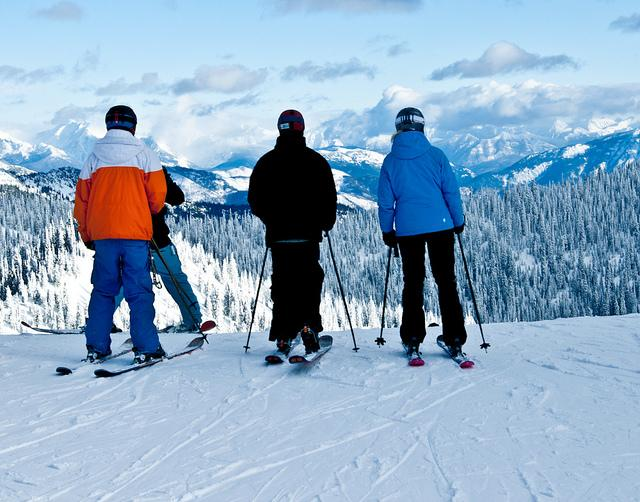What are the people surrounded by?

Choices:
A) coyotes
B) snow
C) eels
D) potted shrubbery snow 